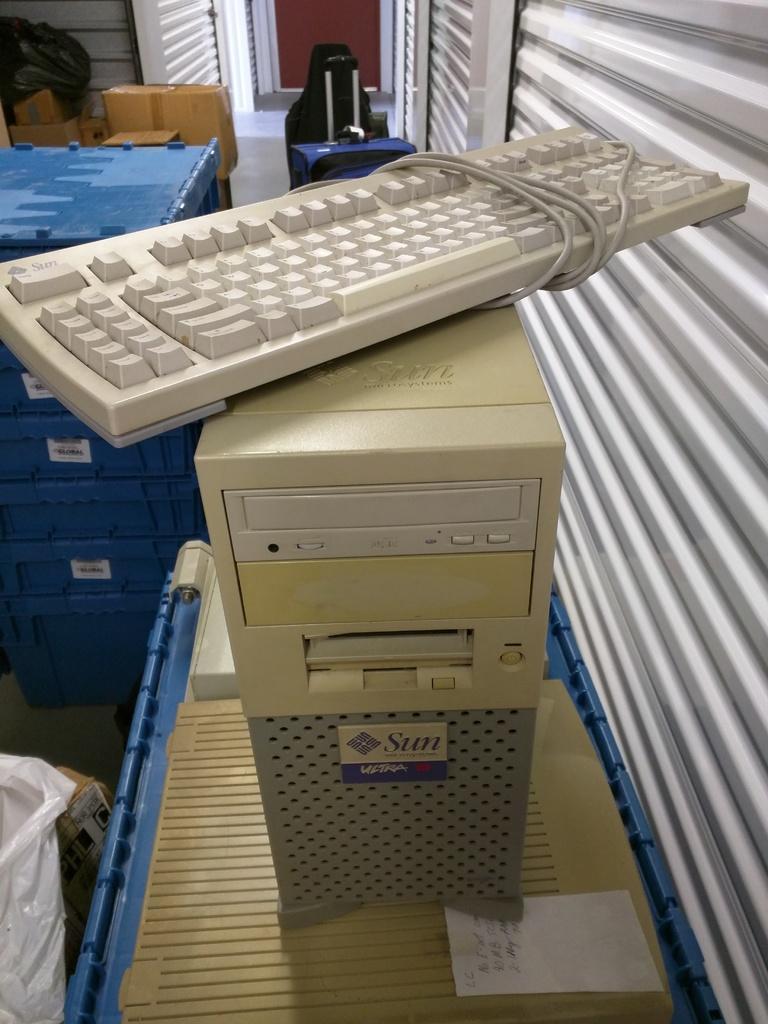Please provide a concise description of this image. In this image, we can see a keyboard on the CPU which is on the table beside the shutter. There are containers on the left side of the image. 